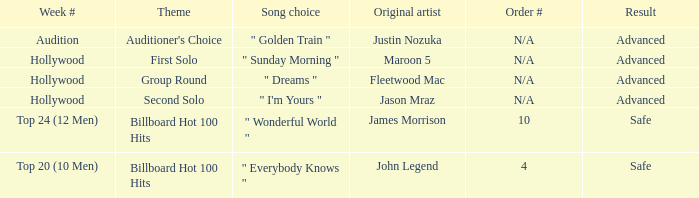What are all the results of songs is " golden train " Advanced. 